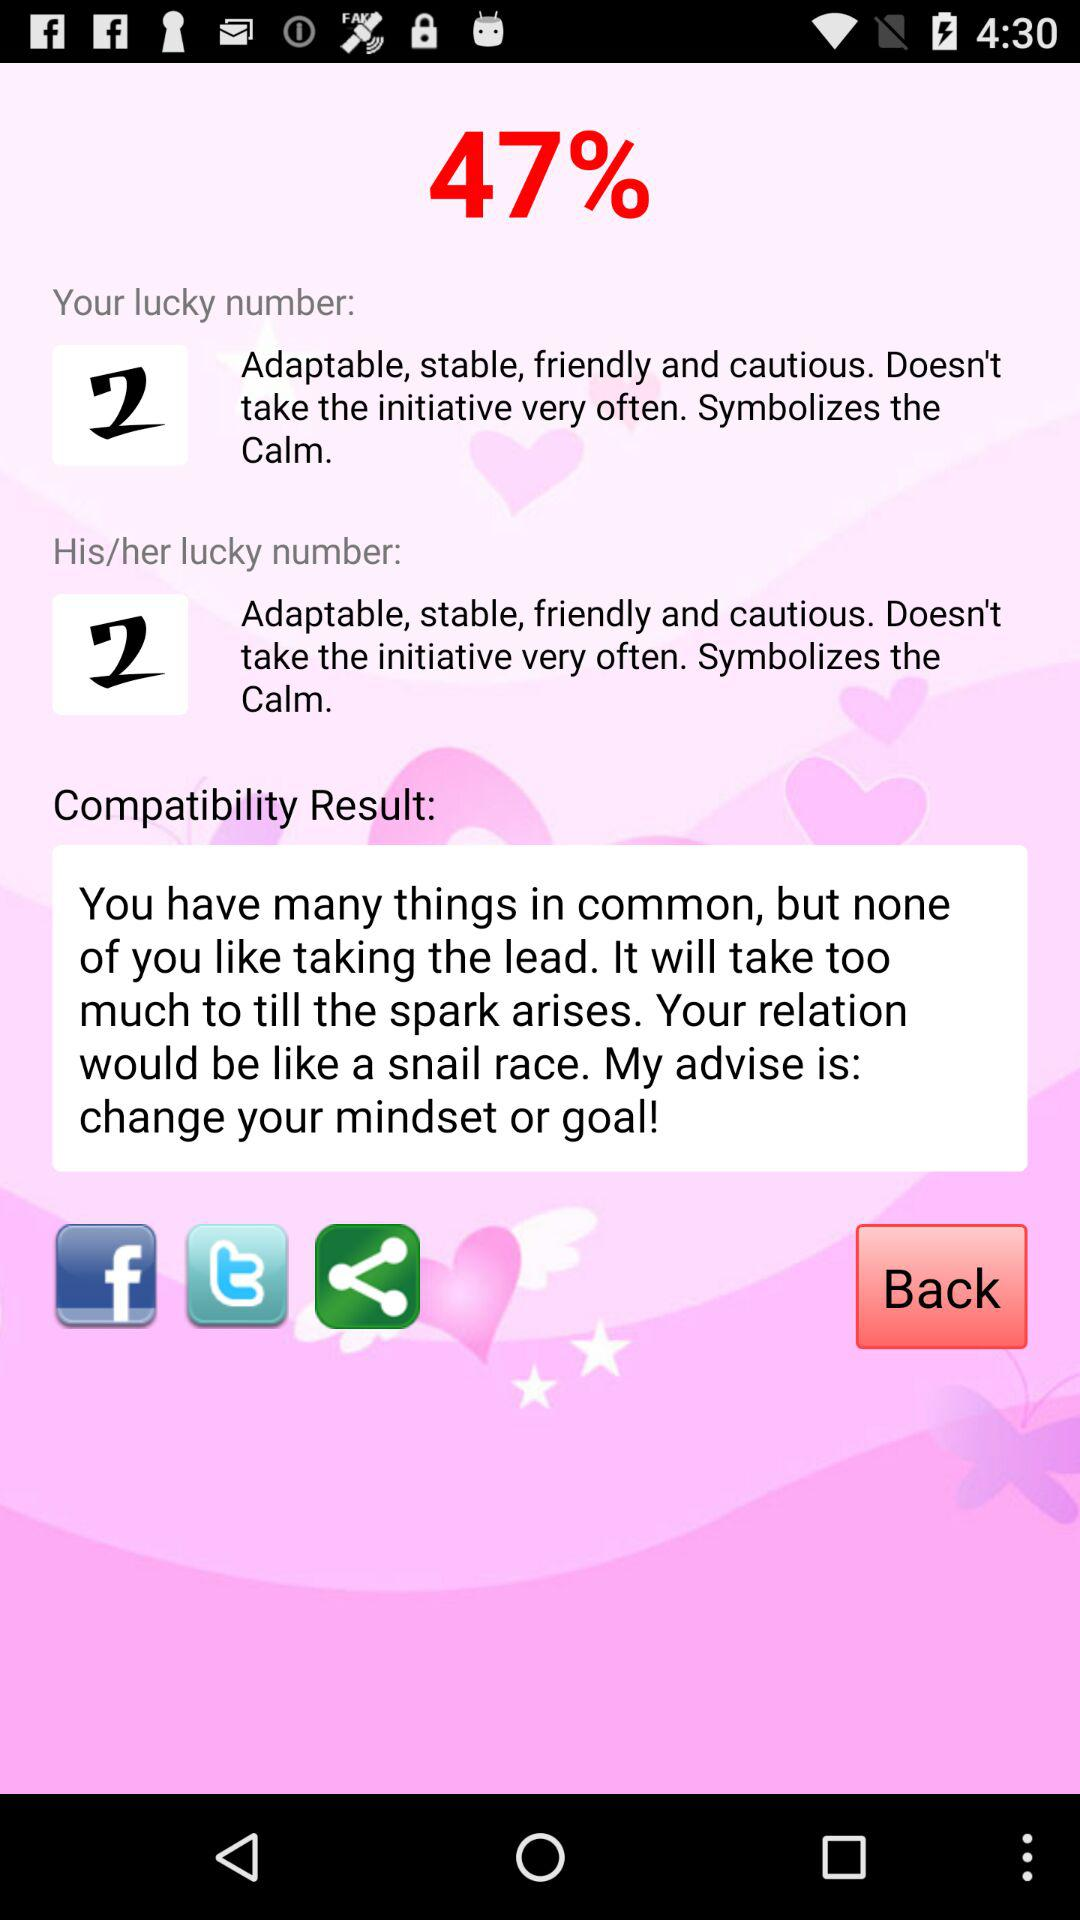What is the shown percentage? The shown percentage is 47%. 